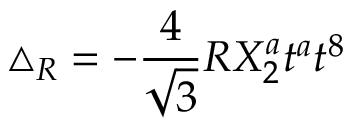Convert formula to latex. <formula><loc_0><loc_0><loc_500><loc_500>\triangle _ { R } = - \frac { 4 } { \sqrt { 3 } } R X _ { 2 } ^ { a } t ^ { a } t ^ { 8 }</formula> 